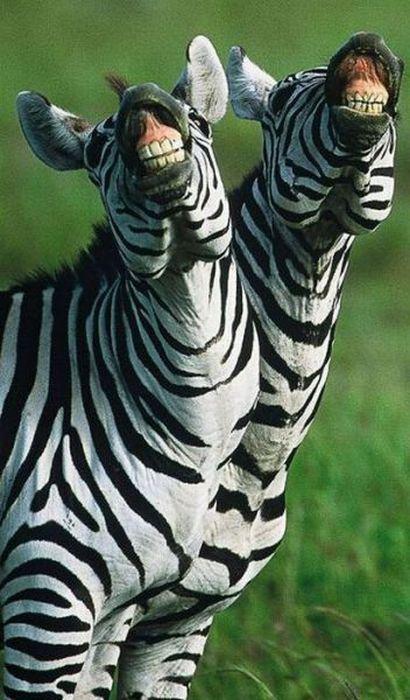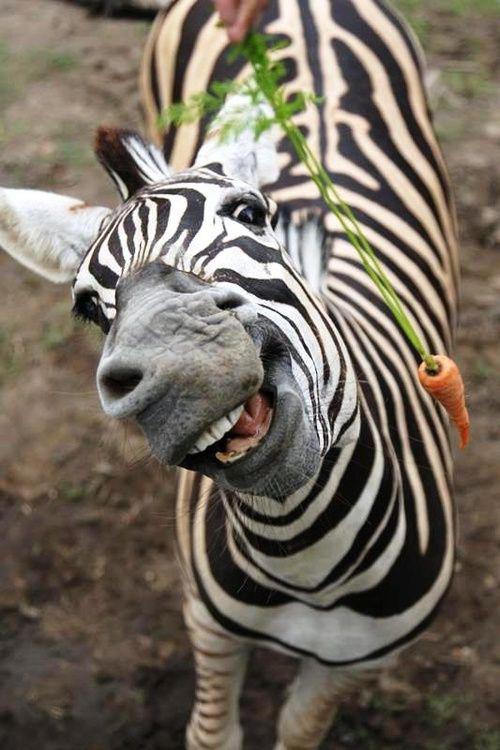The first image is the image on the left, the second image is the image on the right. Given the left and right images, does the statement "There are at least four zebras in total." hold true? Answer yes or no. No. The first image is the image on the left, the second image is the image on the right. Examine the images to the left and right. Is the description "All zebras are showing their teeth as if braying, and at least one image features two zebras side-by-side." accurate? Answer yes or no. Yes. 